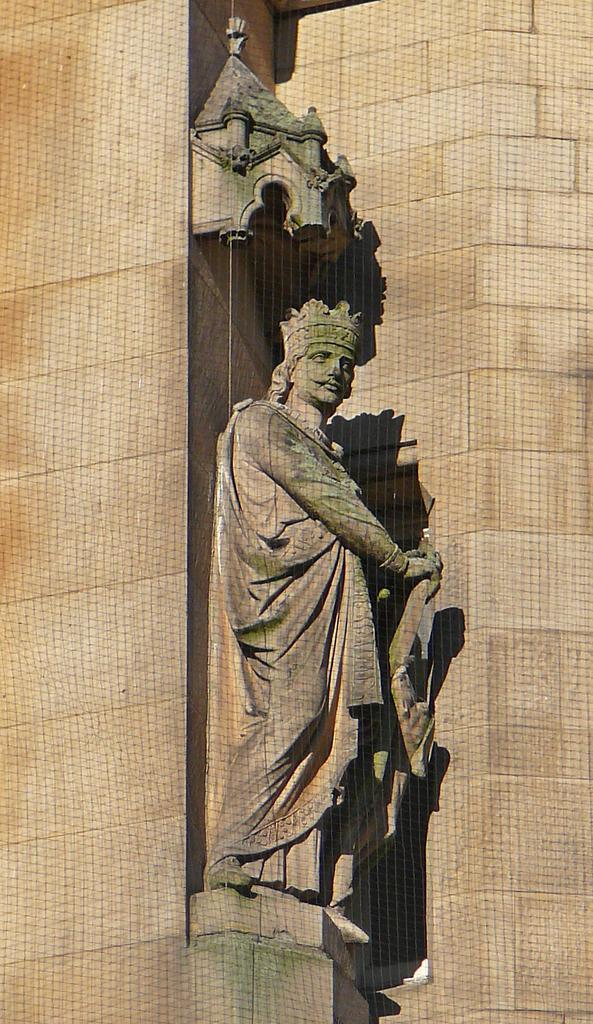Could you give a brief overview of what you see in this image? Here there is a sculpture of a man, this is wall. 